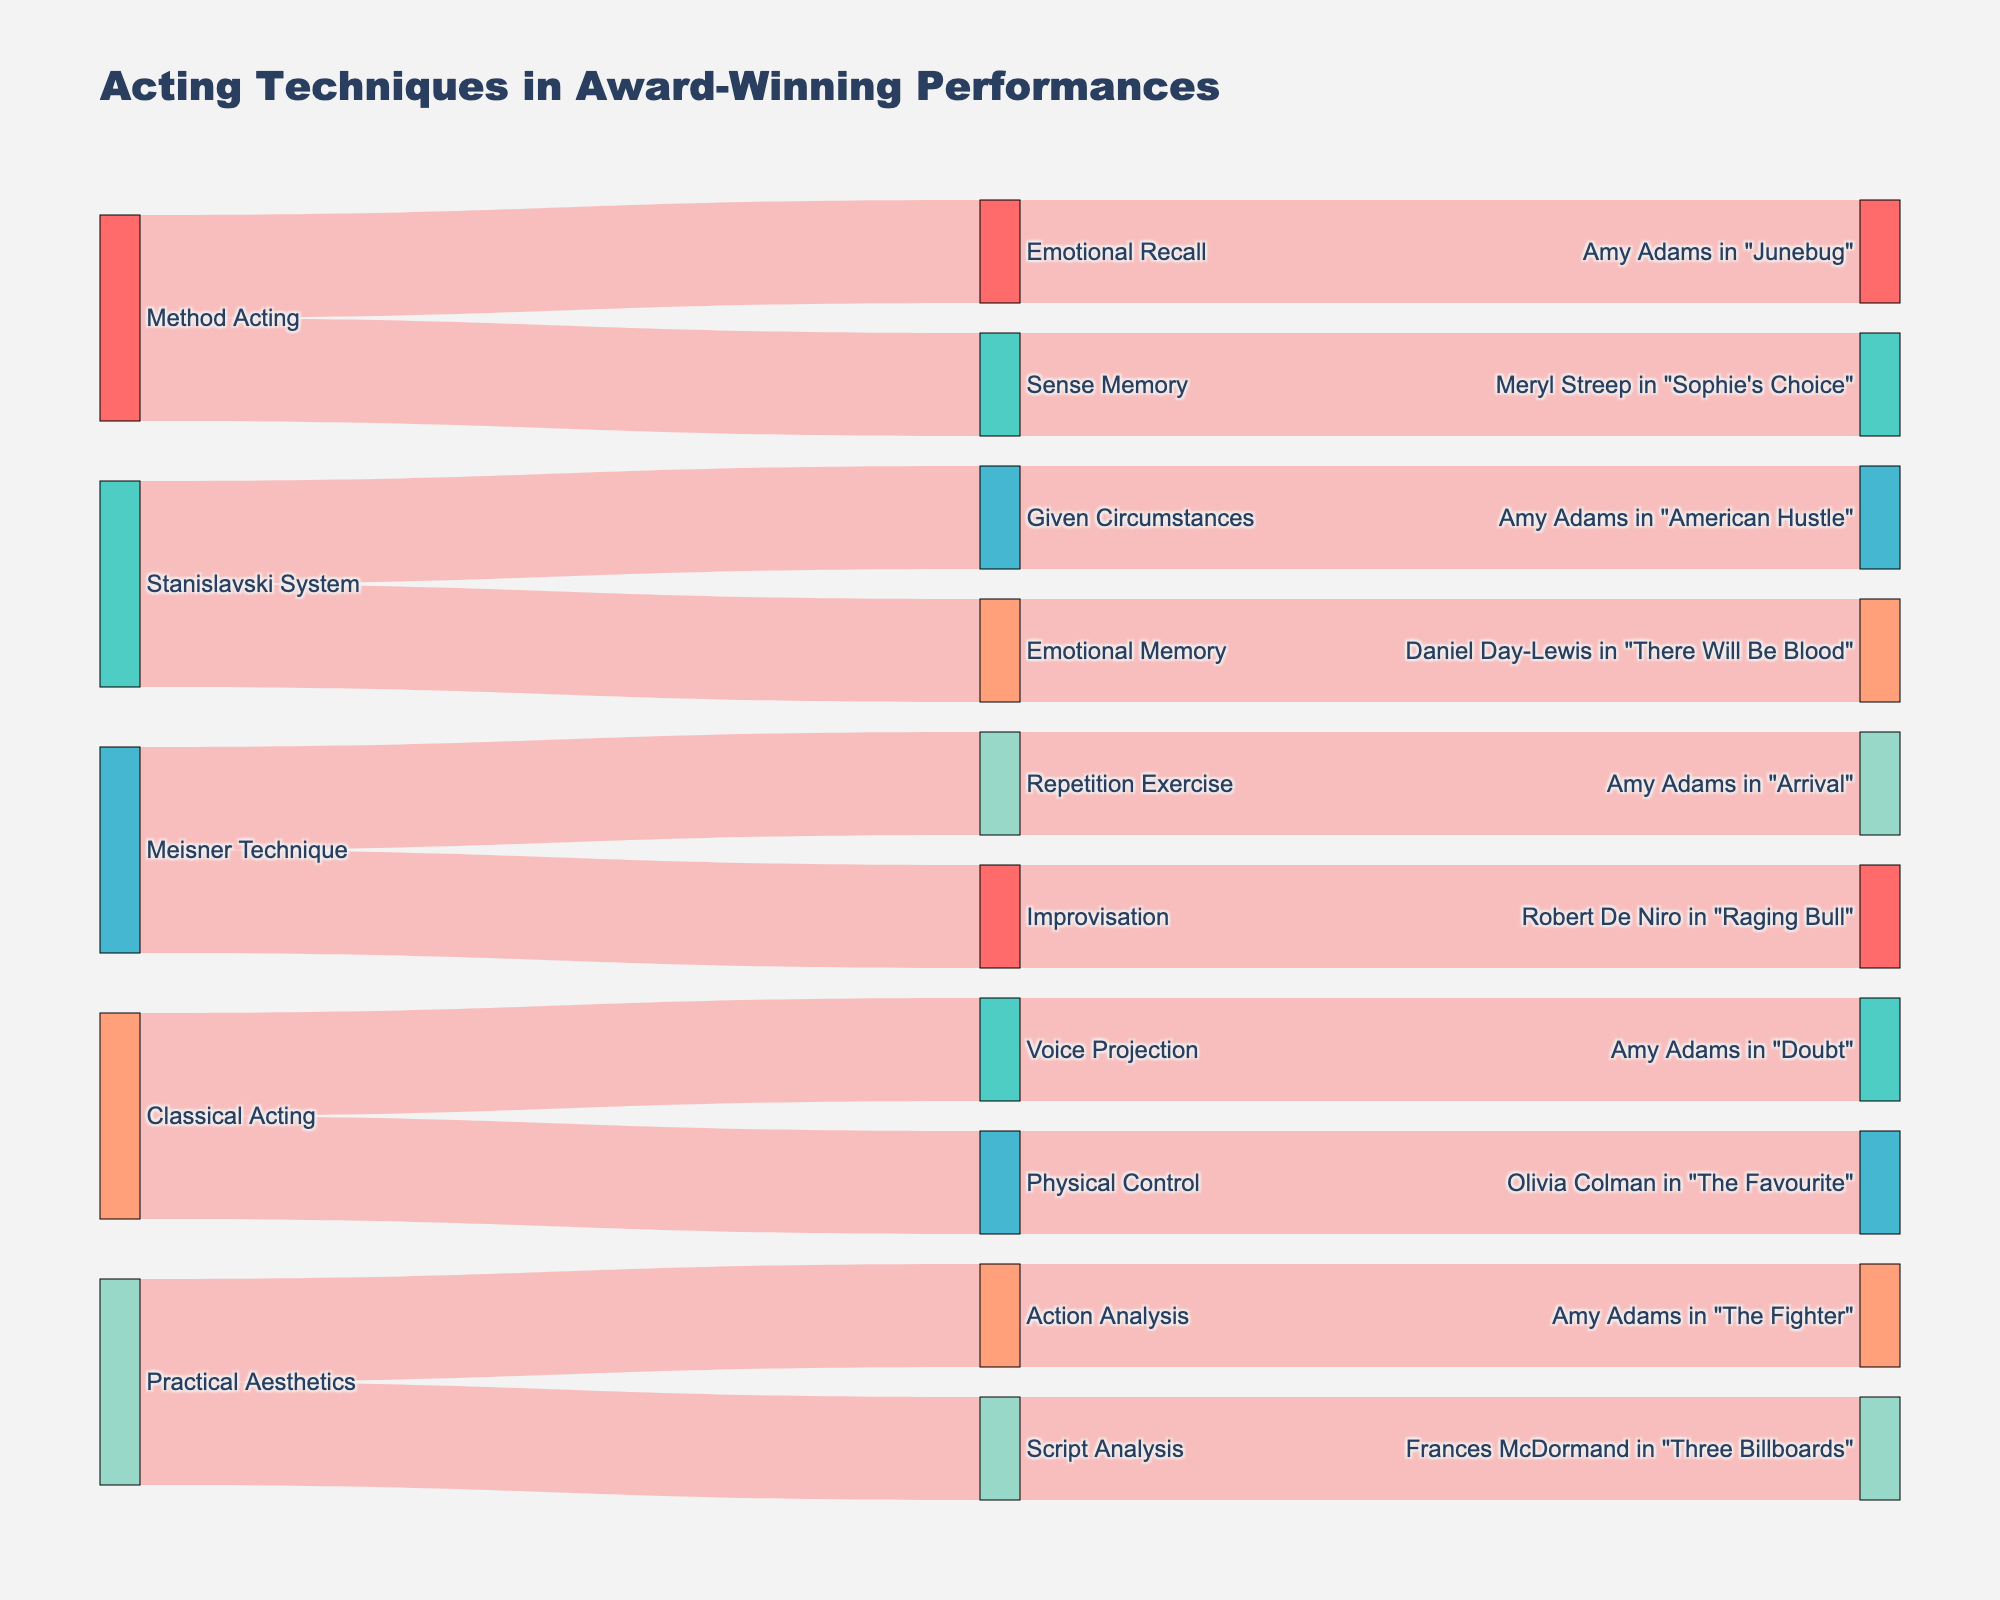what is the title of the plot? The title is usually displayed prominently above or at the top of the plot. It provides a brief description of what the plot is about.
Answer: Acting Techniques in Award-Winning Performances How many techniques are shown in the plot? Techniques are found in the middle layer of the Sankey diagram, connecting sources and performances. Count the number of unique technique labels.
Answer: 8 Which acting technique is associated with the most Amy Adams' performances? Identify all branches leading to and from Amy Adams' performances, then count and compare frequencies of different techniques associated with them.
Answer: Practical Aesthetics What is the total number of performances that used the Meisner Technique? Look at the visual connections from the Meisner Technique node to the performance nodes. Count the number of connections (links) flowing from the Meisner Technique.
Answer: 2 Is there any acting technique linked to both an Oscar win and an Oscar nomination? Check each technique if it connects to both performances with an Oscar nomination (e.g., Amy Adams in "Arrival") and performances with an Oscar win (e.g., Robert De Niro in "Raging Bull").
Answer: Meisner Technique Which techniques led to an Oscar win for a performance? Follow the branches in the Sankey diagram from techniques to performances, then identify which performances are labeled as Oscar Wins.
Answer: Improvisation, Emotional Memory, Script Analysis, Physical Control, Sense Memory Compare the number of techniques used by Amy Adams to those used by Meryl Streep. Which actor used more techniques? Identify all techniques connected to Amy Adams' and Meryl Streep's performances, then count and compare the totals. Amy Adams used 5 techniques (Emotional Recall, Given Circumstances, Repetition Exercise, Voice Projection, Action Analysis), whilst Meryl Streep used 1 technique (Sense Memory).
Answer: Amy Adams used more techniques How many acting sources are depicted in the Sankey diagram? Acting sources are found in the leftmost layer of the Sankey diagram. Count the number of unique source labels.
Answer: 4 Which actor appears in the most award-winning performances in the plot? Examine all performance nodes to identify the associated actors, then count how frequently each actor appears. Amy Adams appears most frequently.
Answer: Amy Adams What is the common technique between Amy Adams' performances in "Arrival" and "American Hustle"? Trace both performances back to their respective techniques and check if any technique is common. Both performances have no common technique.
Answer: None 